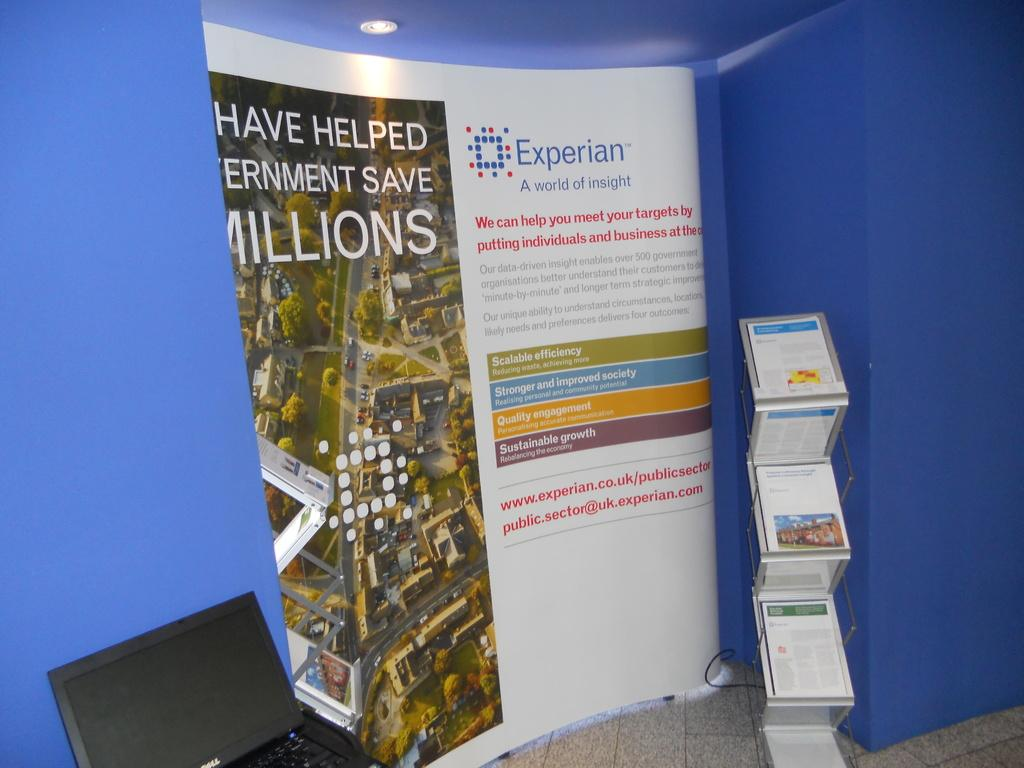<image>
Summarize the visual content of the image. A display from Experian advertises "a world of insight" 